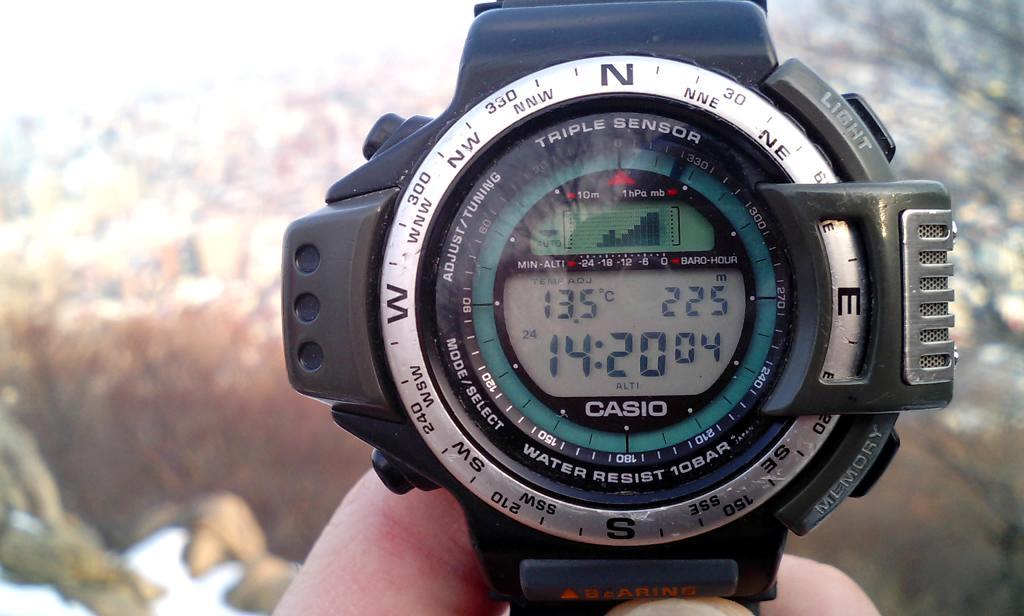What brand is the watch?
Provide a succinct answer. Casio. What is the time displayed?
Provide a short and direct response. 14:20. 